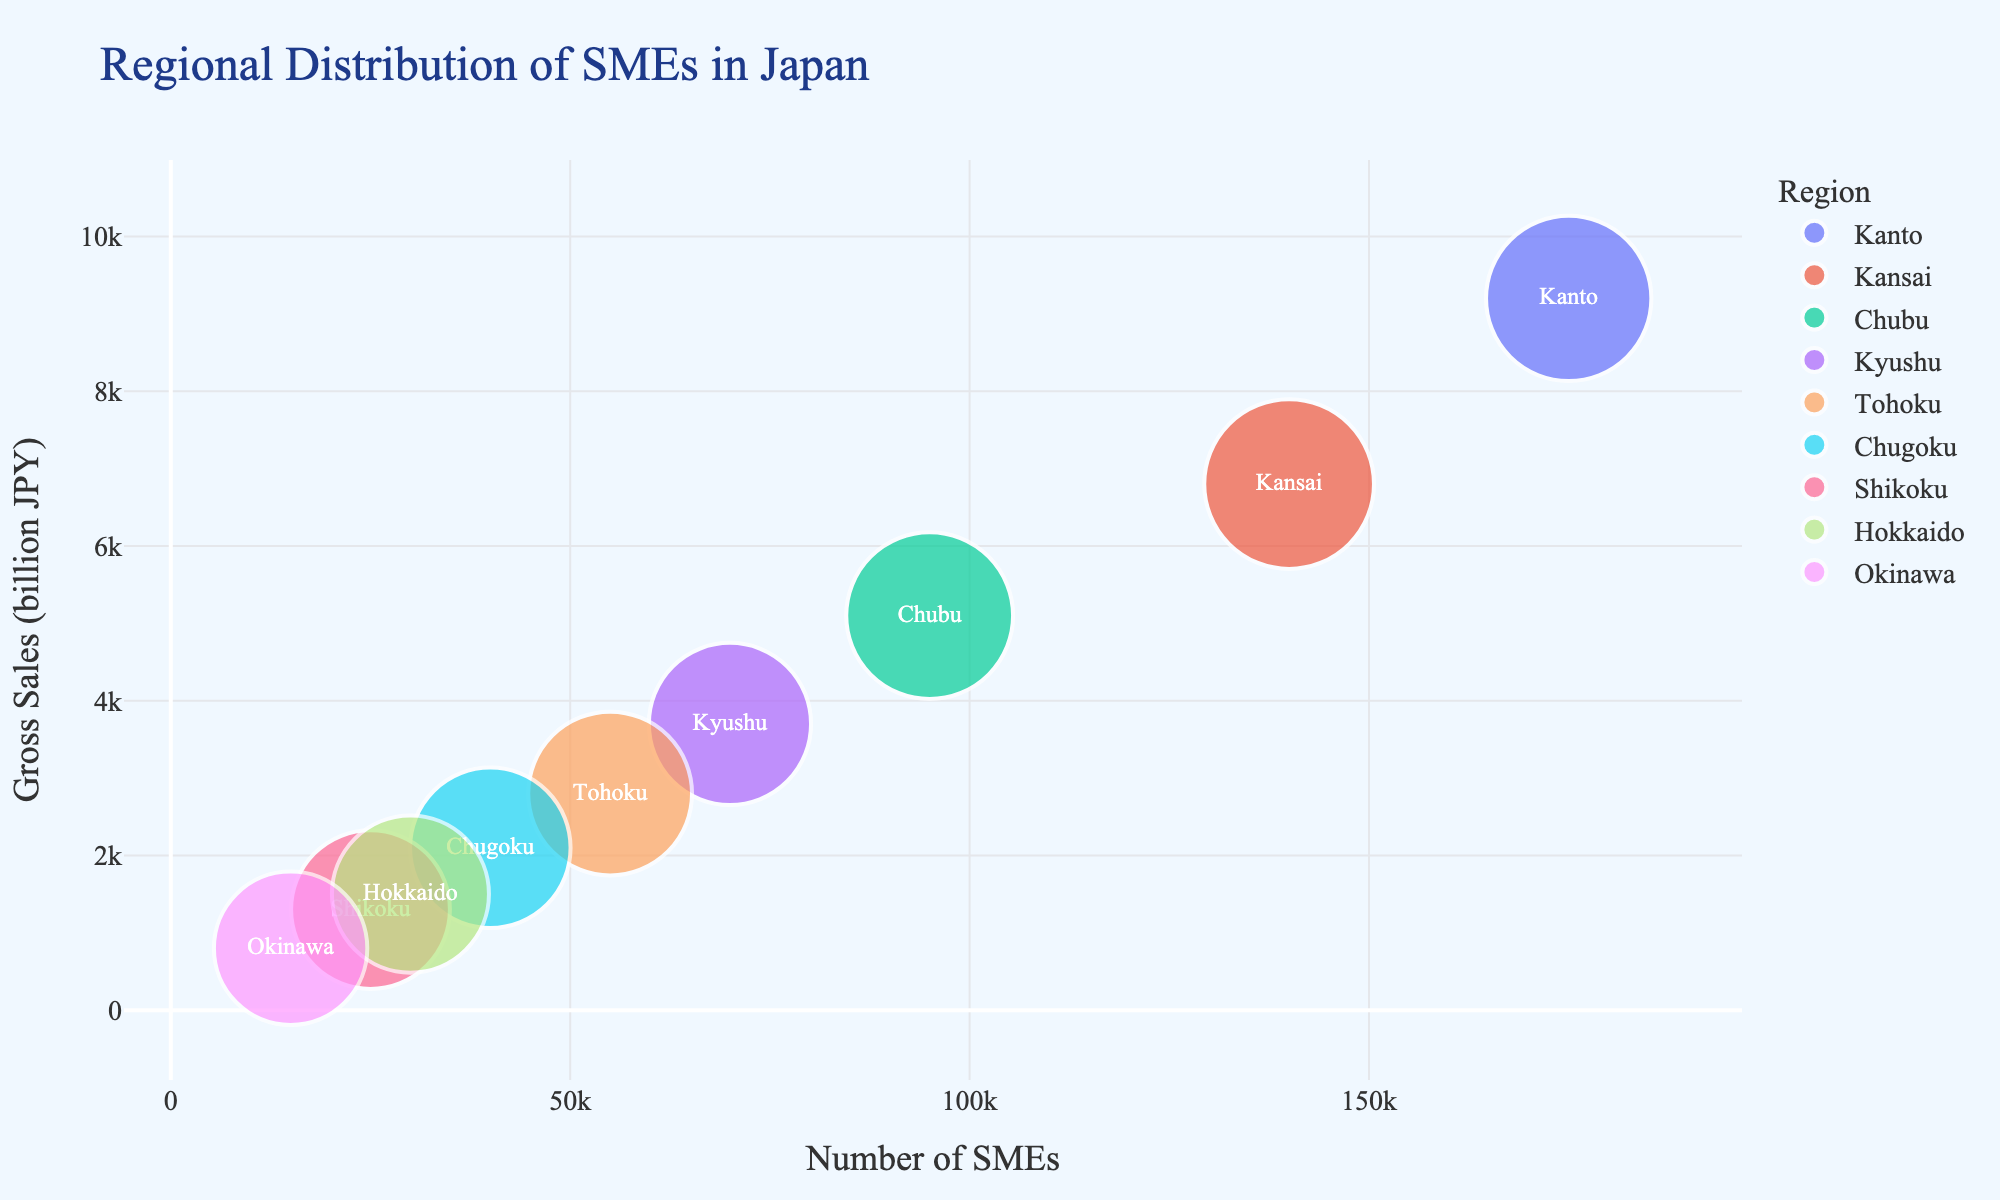What is the region with the highest number of SMEs? To find the region with the highest number of SMEs, look at the x-axis (Number of SMEs) and find the data point farthest to the right.
Answer: Kanto What is the gross sales value for the Kyushu region? Locate the bubble labeled "Kyushu" and refer to the y-axis to find its Gross Sales (in billion JPY) value.
Answer: 3700 Comparing Kansai and Chubu, which region has higher gross sales? Locate the bubbles for Kansai and Chubu and compare their y-axis values. Kansai's bubble is higher on the y-axis than Chubu's bubble.
Answer: Kansai Which region has the smallest average years in business? The size of the bubbles represents the average years in business. The smallest sized bubble will indicate the region with the smallest average years in business.
Answer: Okinawa How many regions have gross sales of more than 5000 billion JPY? Identify and count the regions whose bubbles are above the 5000 mark on the y-axis.
Answer: 2 What is the relationship between the number of SMEs and the gross sales for regions in Japan? Observe the overall trend and direction of the bubbles in the scatter plot. Generally, as the number of SMEs increases (x-axis), the gross sales (y-axis) also increase.
Answer: Positive correlation What is the median number of SMEs among the regions? List the number of SMEs for all regions: 15000, 25000, 30000, 40000, 55000, 70000, 95000, 140000, and 175000. The median value is the middle value when ordered.
Answer: 55000 Which region has had SMEs in business the longest on average? The largest bubble indicates the longest average years in business. The region with the largest bubble is Kansai.
Answer: Kansai How does the number of SMEs in Tohoku compare to that in Shikoku? Locate the bubbles for Tohoku and Shikoku and compare their positions on the x-axis. Tohoku's bubble is farther to the right than Shikoku's bubble.
Answer: Tohoku has more Which regions have fewer than 40000 SMEs? Identify the bubbles for regions that are to the left of the 40000 mark on the x-axis. These regions are Chugoku, Shikoku, Hokkaido, and Okinawa.
Answer: Chugoku, Shikoku, Hokkaido, Okinawa 